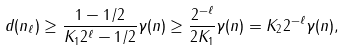<formula> <loc_0><loc_0><loc_500><loc_500>d ( n _ { \ell } ) \geq \frac { 1 - 1 / 2 } { K _ { 1 } 2 ^ { \ell } - 1 / 2 } \gamma ( n ) \geq \frac { 2 ^ { - \ell } } { 2 K _ { 1 } } \gamma ( n ) = K _ { 2 } 2 ^ { - \ell } \gamma ( n ) ,</formula> 